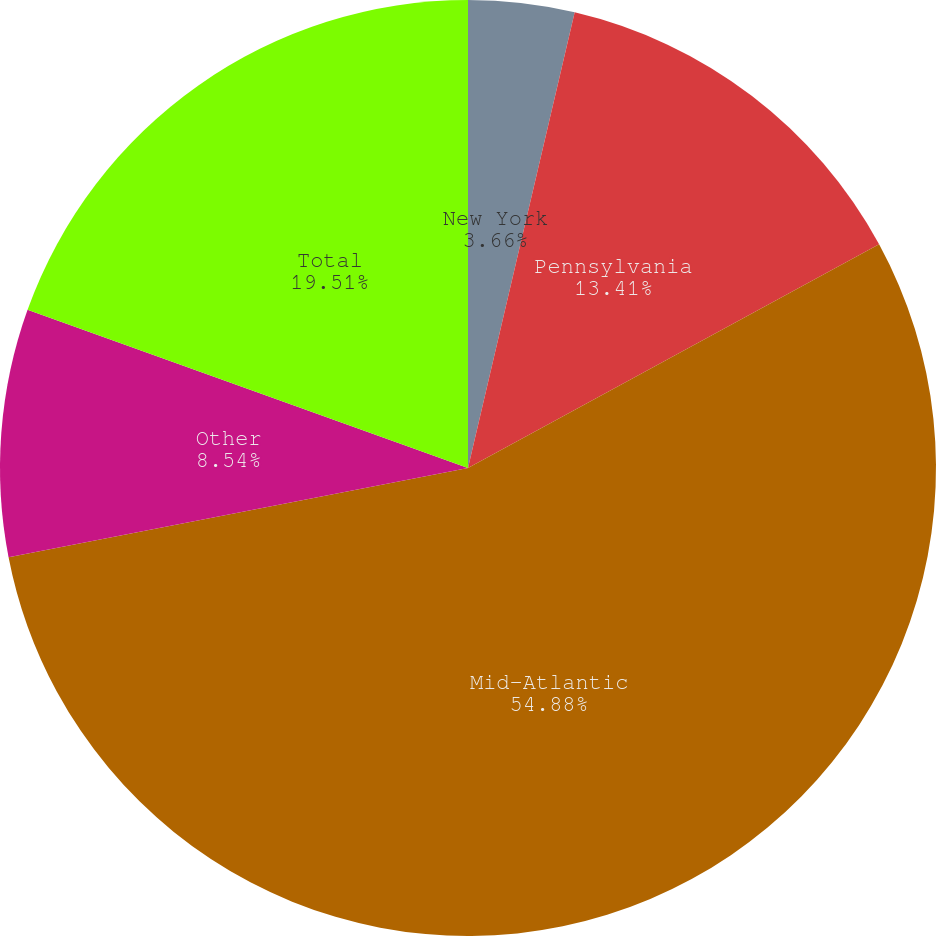Convert chart. <chart><loc_0><loc_0><loc_500><loc_500><pie_chart><fcel>New York<fcel>Pennsylvania<fcel>Mid-Atlantic<fcel>Other<fcel>Total<nl><fcel>3.66%<fcel>13.41%<fcel>54.88%<fcel>8.54%<fcel>19.51%<nl></chart> 